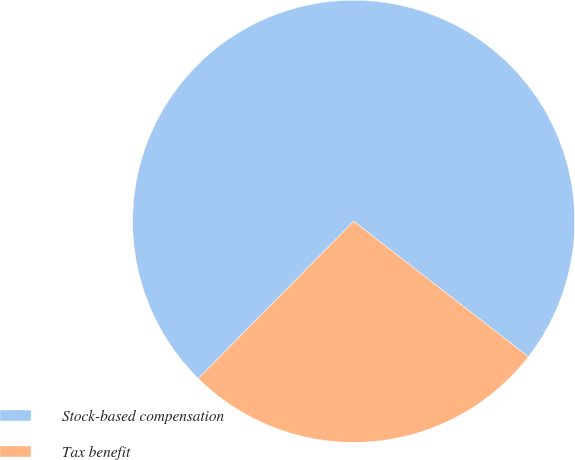Convert chart to OTSL. <chart><loc_0><loc_0><loc_500><loc_500><pie_chart><fcel>Stock-based compensation<fcel>Tax benefit<nl><fcel>73.09%<fcel>26.91%<nl></chart> 